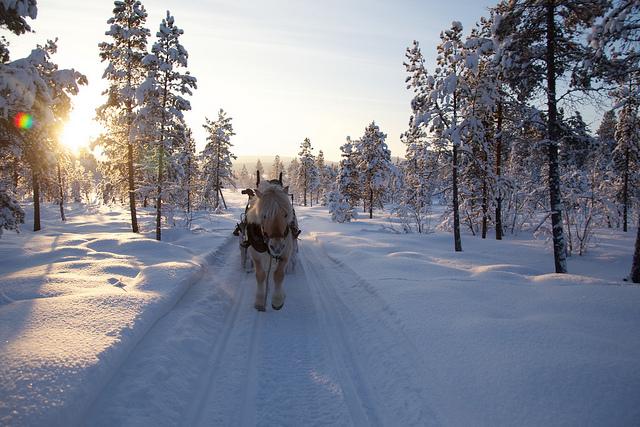Is there snow on the ground?
Write a very short answer. Yes. Is the horse pulling a cart?
Short answer required. Yes. What kind of horse is this?
Short answer required. Clydesdale. 